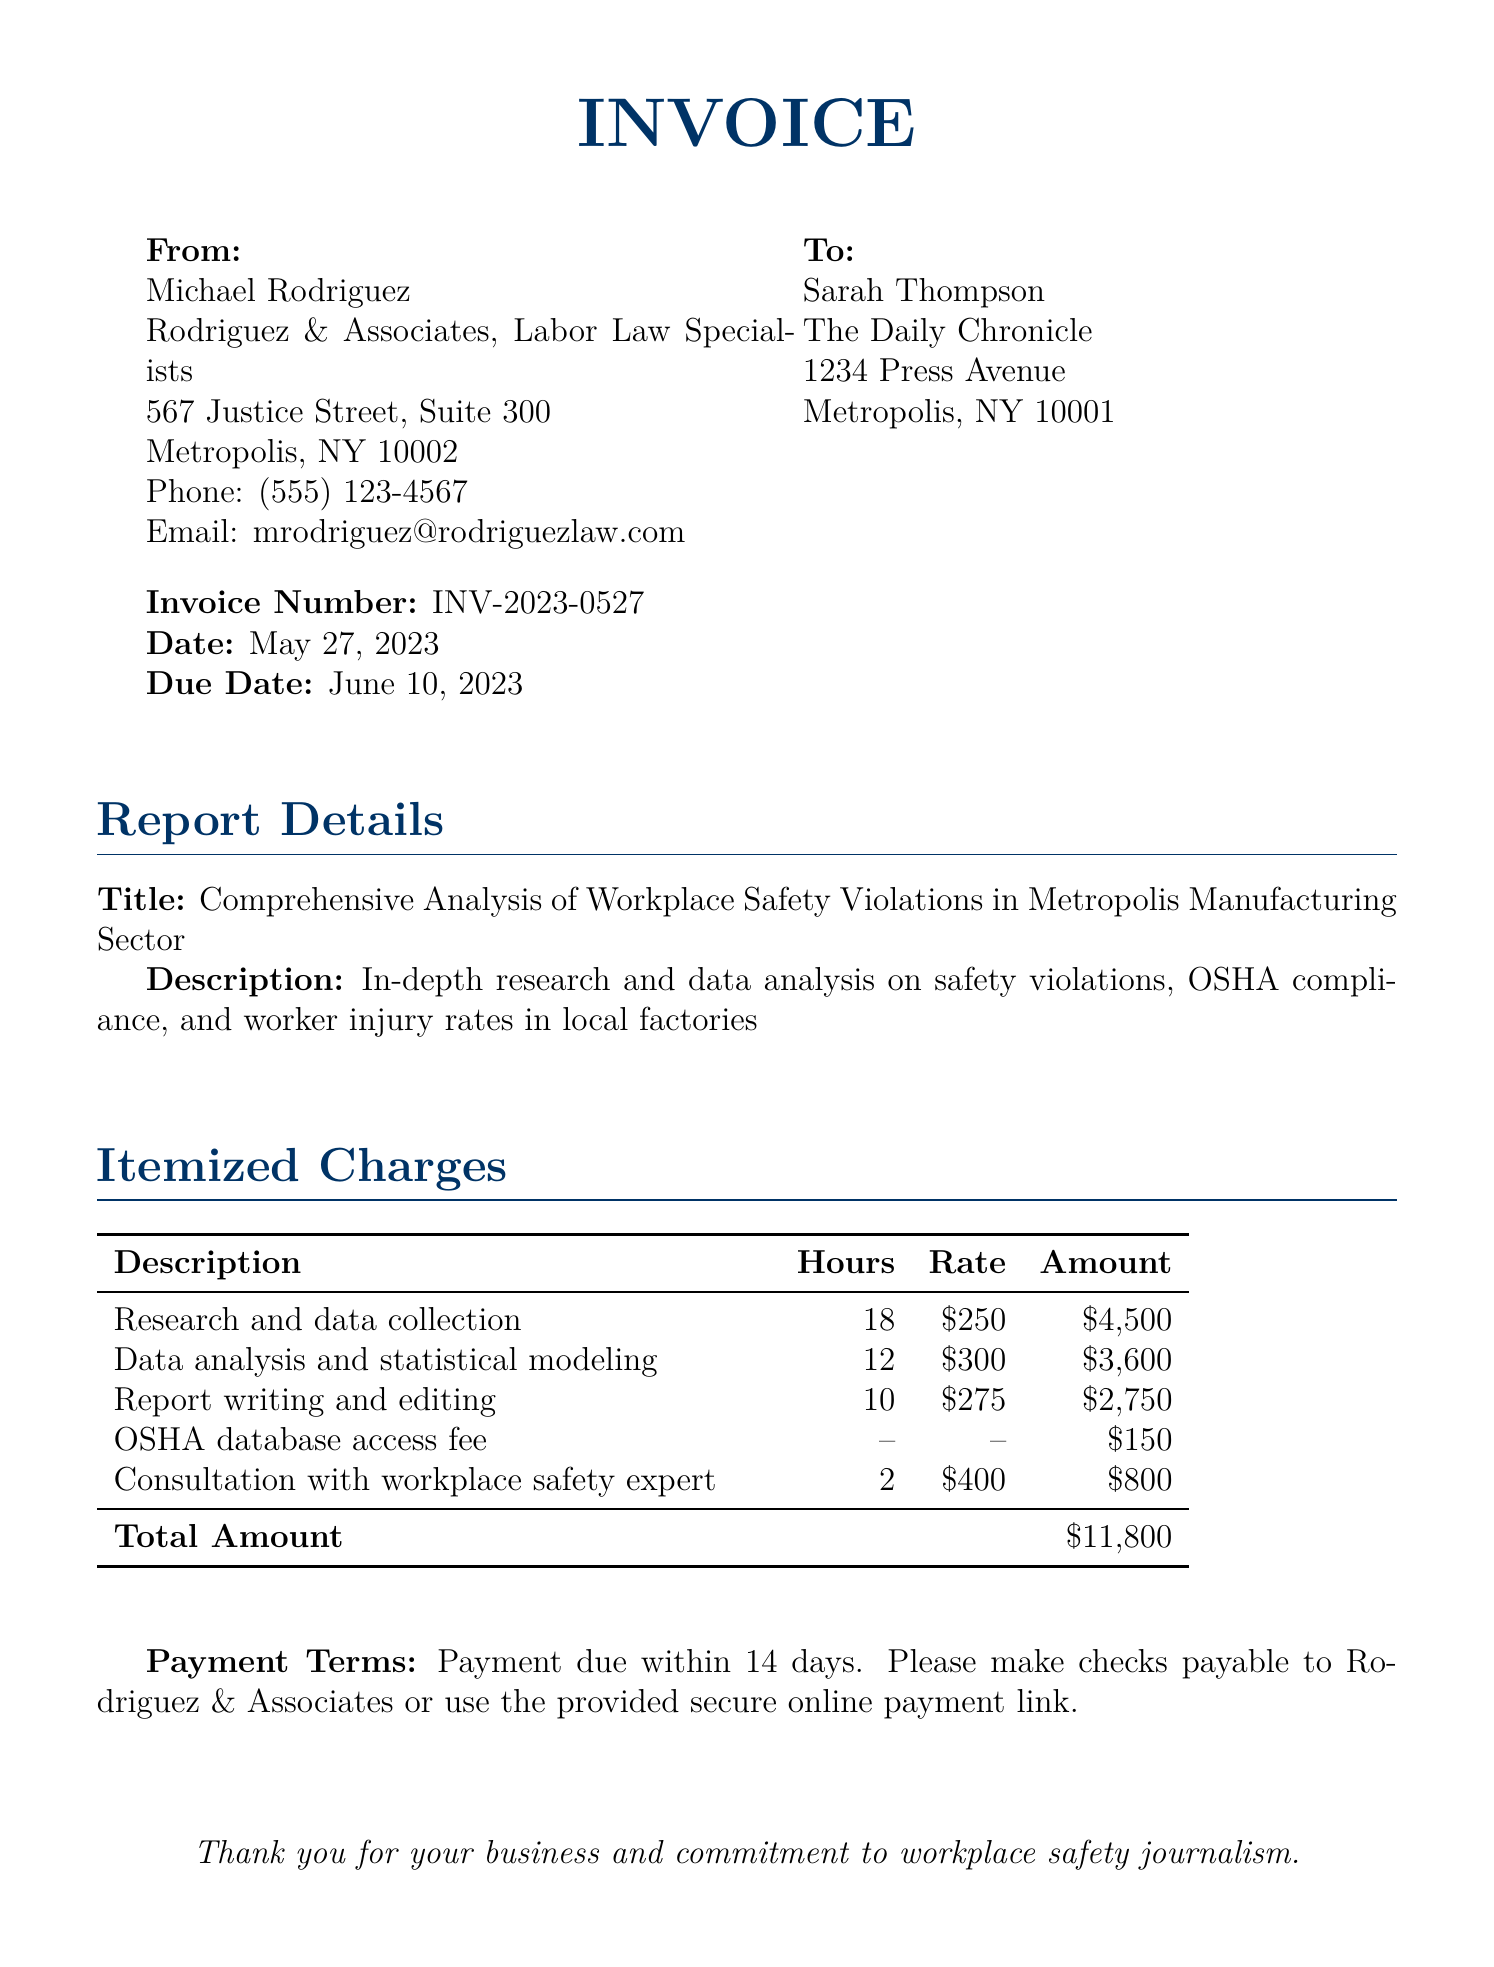What is the invoice number? The invoice number is a unique identifier for the bill detailed in the document. It can be found near the top of the invoice.
Answer: INV-2023-0527 Who is the attorney listed on the invoice? The attorney's name and firm are provided at the top of the document.
Answer: Michael Rodriguez What is the due date for payment? The due date specifies when the payment is to be made and is listed in the invoice details.
Answer: June 10, 2023 How many hours were spent on research and data collection? This information is found in the itemized charges section, which details the hours spent on each task.
Answer: 18 What is the total amount due on the invoice? The total amount is the sum of all itemized charges, found at the end of the itemized charges table.
Answer: $11,800 What is the rate for data analysis and statistical modeling? The rate for this specific service is clearly indicated in the itemized charges table.
Answer: $300 How many hours were billed for consultation with a workplace safety expert? This detail is listed in the itemized charges section, specifying the hours billed for each task.
Answer: 2 What is the description of the report? The report description provides a summary of what research and analysis were conducted, found in the report details section.
Answer: In-depth research and data analysis on safety violations, OSHA compliance, and worker injury rates in local factories What is the consultation rate for the workplace safety expert? The consultation rate is specified in the itemized charges, which lists the costs associated with each service.
Answer: $400 